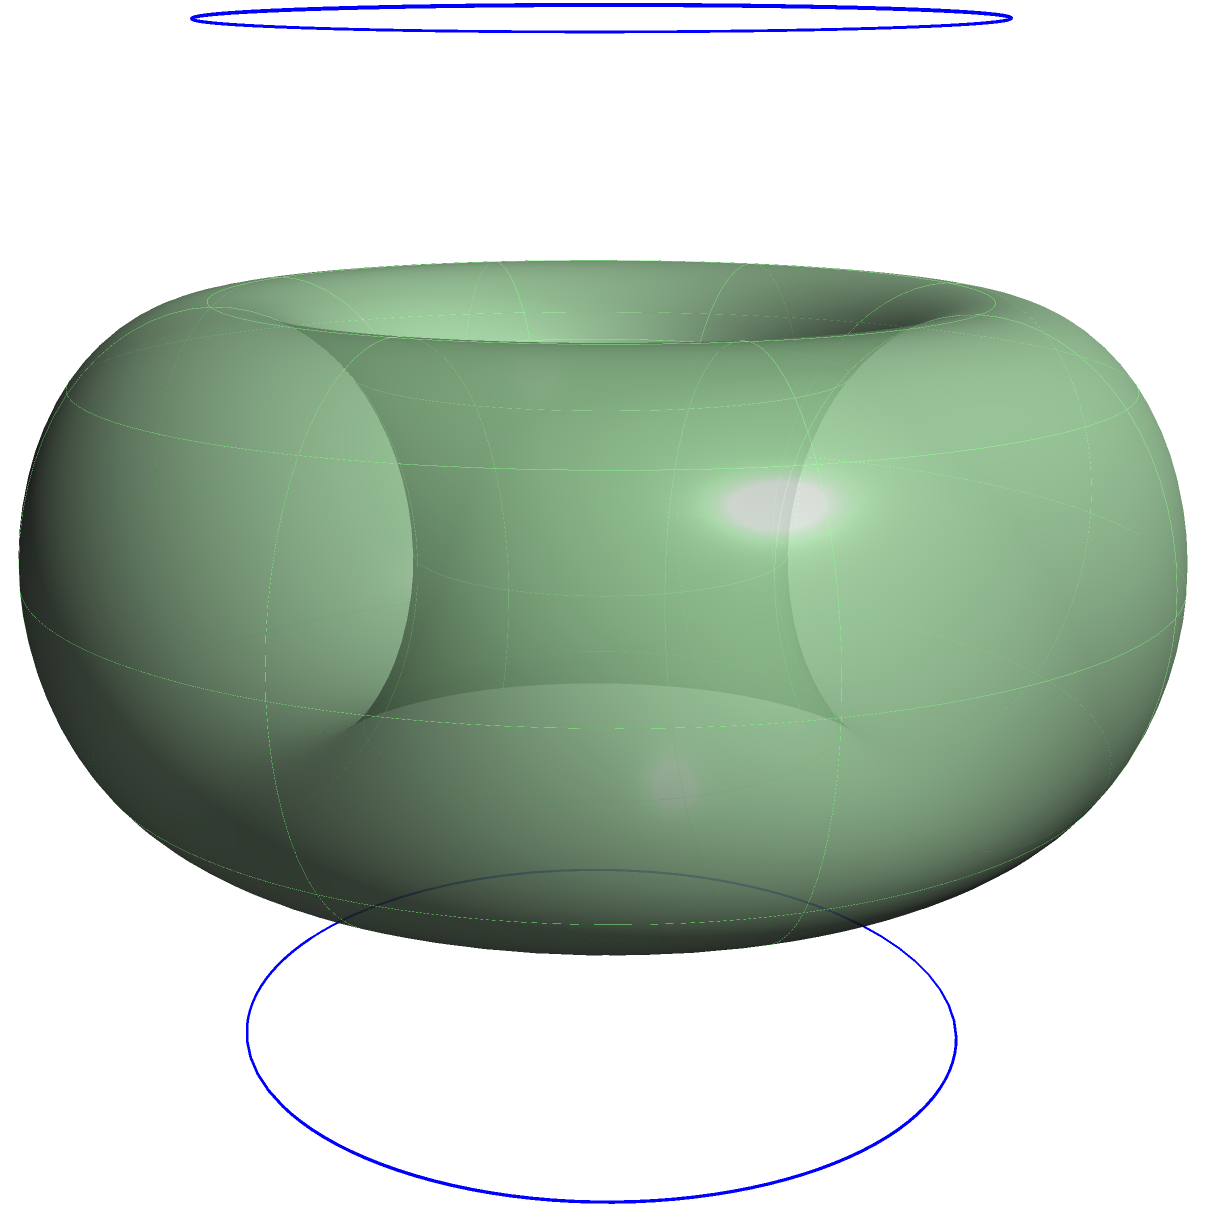As an algorithmic trader familiar with cognitive bias mitigation, consider the surface shown in the image. This surface is topologically equivalent to a torus. How would you classify this surface based on its genus and orientability, and how might this classification relate to identifying and mitigating cognitive biases in financial decision-making? To classify the surface and relate it to cognitive bias mitigation, let's follow these steps:

1. Identify the surface: The image shows a torus-like surface.

2. Determine the genus:
   - The genus of a surface is the number of "holes" it has.
   - A torus has one hole, so its genus is 1.

3. Determine orientability:
   - A surface is orientable if it has two distinct sides.
   - A torus is orientable as it has a well-defined inside and outside.

4. Classification:
   - The surface is a genus-1 orientable surface.

5. Relation to cognitive bias mitigation in algorithmic trading:
   - The torus represents a closed loop, similar to how cognitive biases can create self-reinforcing patterns in decision-making.
   - The genus (hole) can represent the "blind spot" created by cognitive biases.
   - The orientability suggests that we can distinguish between biased and unbiased perspectives.

6. Application to financial decision-making:
   - Recognize that trading decisions may follow cyclical patterns (like the surface of the torus).
   - Identify the "holes" in reasoning that cognitive biases create.
   - Develop strategies to navigate both the "inside" and "outside" perspectives of a trading situation.

7. Mitigation techniques:
   - Use the topological structure to map out decision processes and identify where biases might occur.
   - Implement checks and balances at key points in the trading algorithm to counteract the cyclical nature of biases.
   - Regularly "flip" perspectives (like the orientability of the surface) to challenge assumptions and biases.
Answer: Genus-1 orientable surface; guides bias mitigation by mapping decision cycles, identifying blind spots, and promoting perspective shifts in algorithmic trading. 